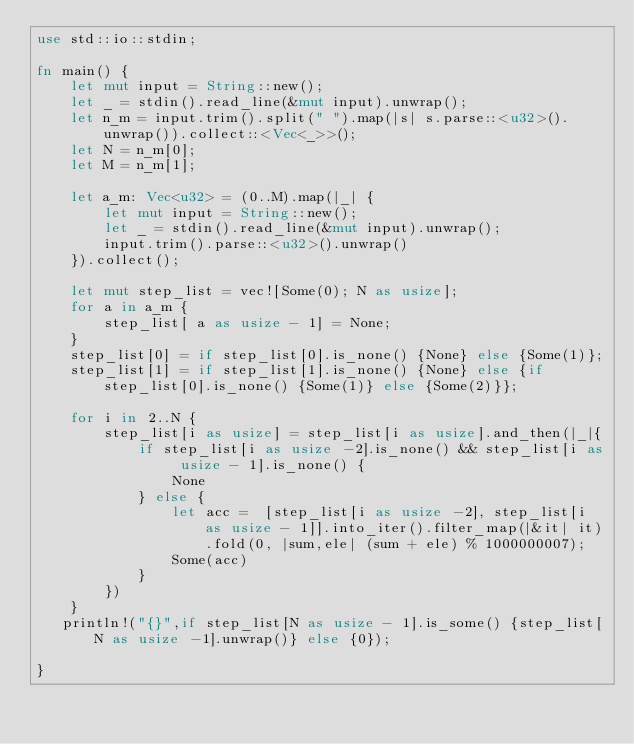Convert code to text. <code><loc_0><loc_0><loc_500><loc_500><_Rust_>use std::io::stdin;

fn main() {
    let mut input = String::new();
    let _ = stdin().read_line(&mut input).unwrap();
    let n_m = input.trim().split(" ").map(|s| s.parse::<u32>().unwrap()).collect::<Vec<_>>();
    let N = n_m[0];
    let M = n_m[1];

    let a_m: Vec<u32> = (0..M).map(|_| {
        let mut input = String::new();
        let _ = stdin().read_line(&mut input).unwrap();
        input.trim().parse::<u32>().unwrap()
    }).collect();

    let mut step_list = vec![Some(0); N as usize];
    for a in a_m {
        step_list[ a as usize - 1] = None;
    }
    step_list[0] = if step_list[0].is_none() {None} else {Some(1)};
    step_list[1] = if step_list[1].is_none() {None} else {if step_list[0].is_none() {Some(1)} else {Some(2)}};

    for i in 2..N {
        step_list[i as usize] = step_list[i as usize].and_then(|_|{
            if step_list[i as usize -2].is_none() && step_list[i as usize - 1].is_none() {
                None
            } else {
                let acc =  [step_list[i as usize -2], step_list[i as usize - 1]].into_iter().filter_map(|&it| it).fold(0, |sum,ele| (sum + ele) % 1000000007);
                Some(acc)
            }
        })
    }
   println!("{}",if step_list[N as usize - 1].is_some() {step_list[N as usize -1].unwrap()} else {0}); 

}
</code> 